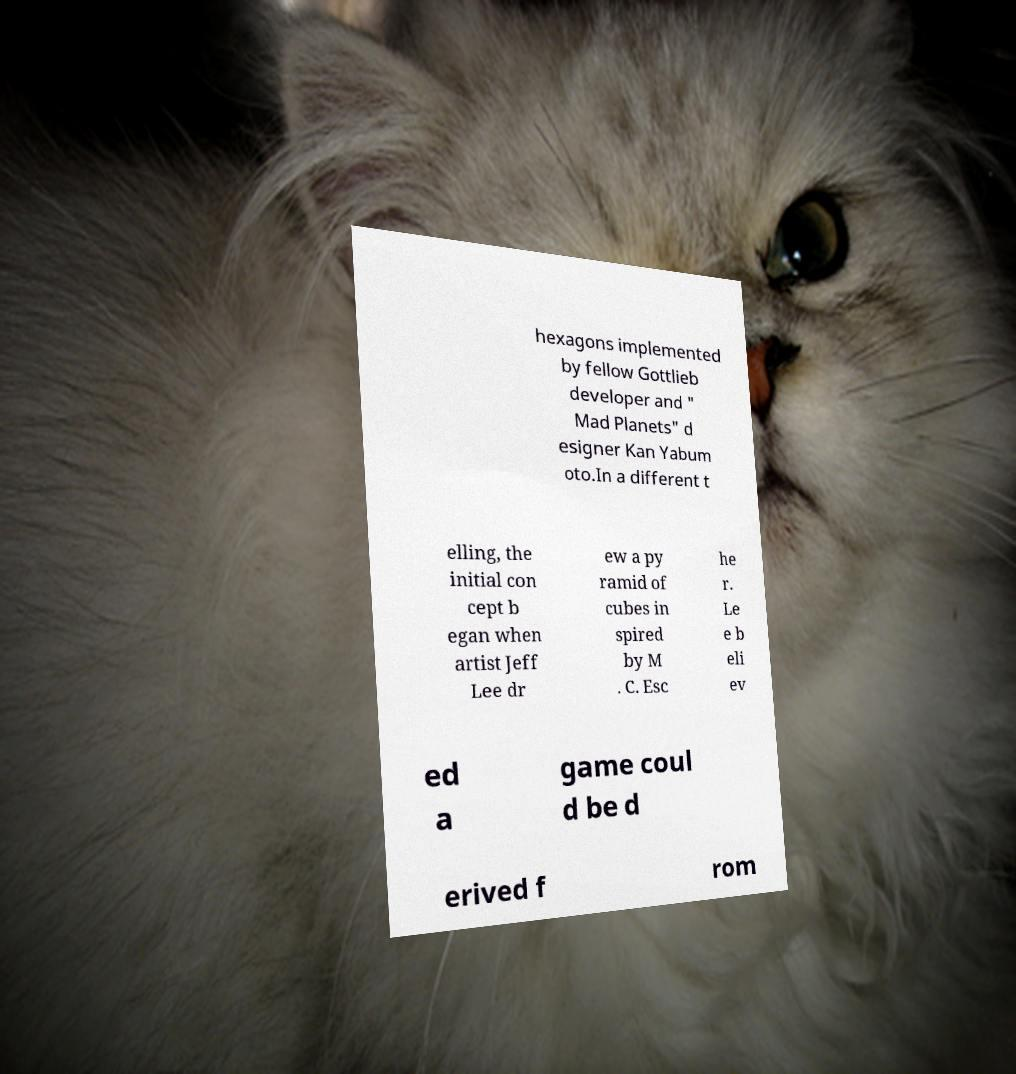What messages or text are displayed in this image? I need them in a readable, typed format. hexagons implemented by fellow Gottlieb developer and " Mad Planets" d esigner Kan Yabum oto.In a different t elling, the initial con cept b egan when artist Jeff Lee dr ew a py ramid of cubes in spired by M . C. Esc he r. Le e b eli ev ed a game coul d be d erived f rom 